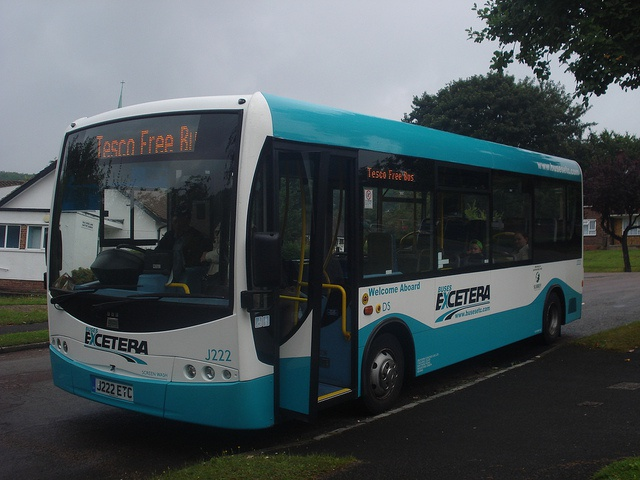Describe the objects in this image and their specific colors. I can see bus in darkgray, black, gray, and teal tones, people in darkgray, black, gray, and teal tones, people in darkgray and black tones, people in black and darkgray tones, and people in black, darkgreen, and darkgray tones in this image. 